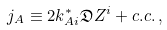Convert formula to latex. <formula><loc_0><loc_0><loc_500><loc_500>j _ { A } \equiv 2 k ^ { * } _ { A i } \mathfrak { D } Z ^ { i } + c . c . \, ,</formula> 